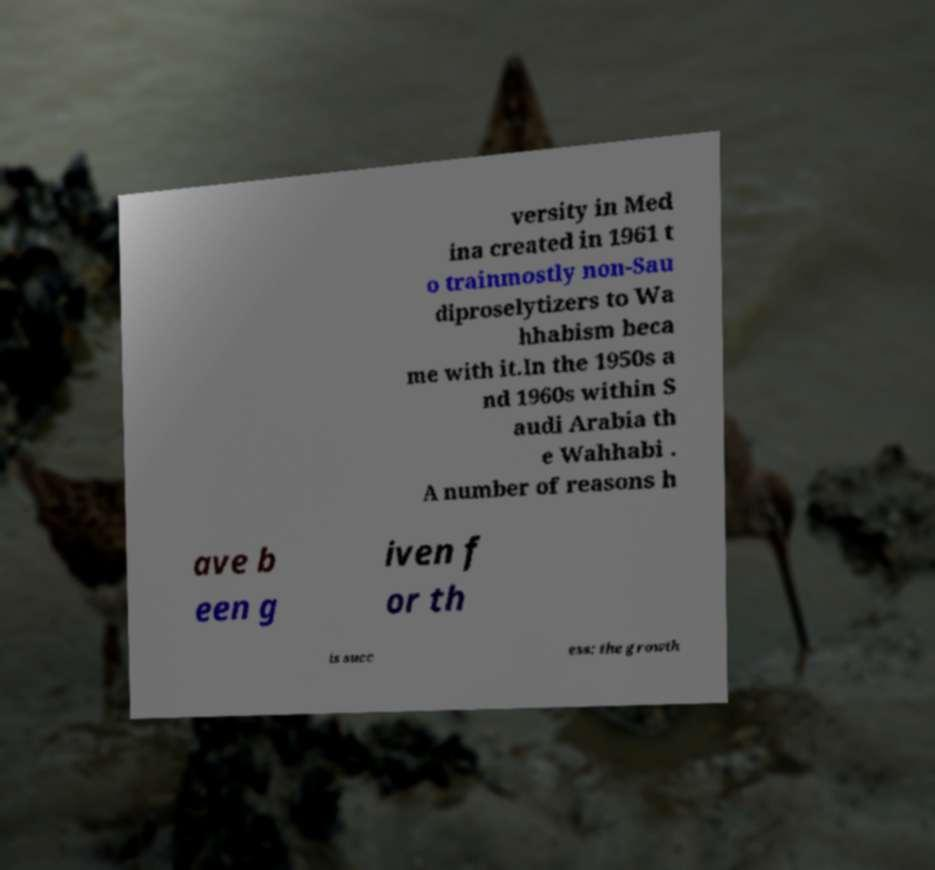Please read and relay the text visible in this image. What does it say? versity in Med ina created in 1961 t o trainmostly non-Sau diproselytizers to Wa hhabism beca me with it.In the 1950s a nd 1960s within S audi Arabia th e Wahhabi . A number of reasons h ave b een g iven f or th is succ ess: the growth 